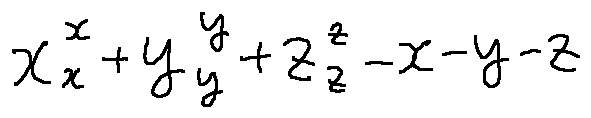Convert formula to latex. <formula><loc_0><loc_0><loc_500><loc_500>x _ { x } ^ { x } + y _ { y } ^ { y } + z _ { z } ^ { z } - x - y - z</formula> 